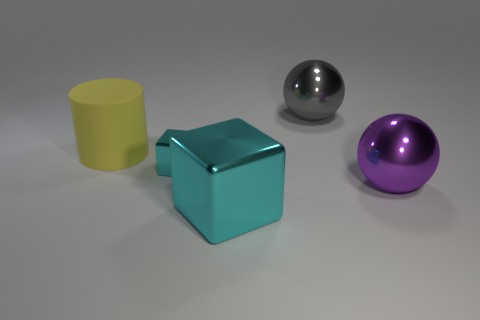Do the object that is right of the large gray thing and the cyan block that is behind the big purple metal thing have the same size?
Keep it short and to the point. No. What number of other objects are there of the same material as the tiny block?
Your response must be concise. 3. What number of shiny things are big gray spheres or cylinders?
Give a very brief answer. 1. Are there fewer small cyan metallic blocks than big balls?
Provide a short and direct response. Yes. Is the size of the yellow cylinder the same as the cyan metallic block that is behind the big cyan metal thing?
Offer a very short reply. No. Is there anything else that has the same shape as the yellow matte object?
Ensure brevity in your answer.  No. How big is the purple thing?
Make the answer very short. Large. Are there fewer small cyan blocks that are in front of the large cyan metal block than tiny red metallic things?
Your response must be concise. No. Do the purple object and the yellow cylinder have the same size?
Offer a terse response. Yes. What is the color of the other cube that is made of the same material as the large cyan cube?
Your answer should be compact. Cyan. 